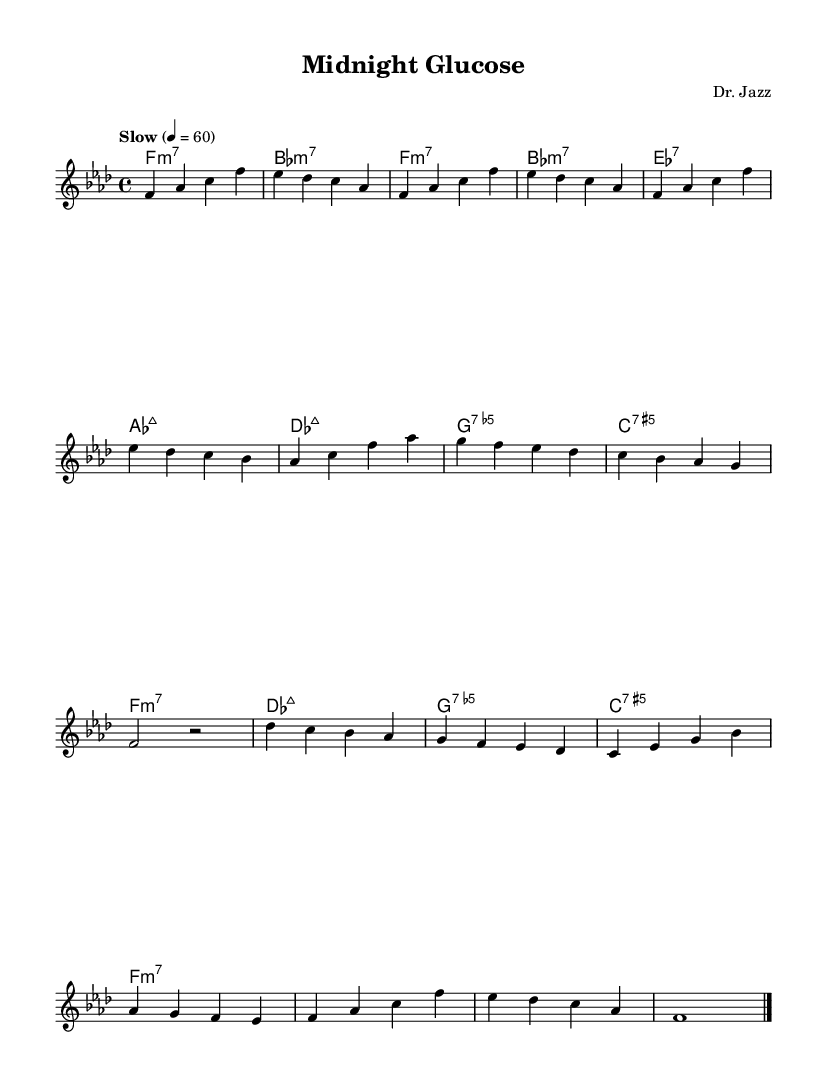What is the key signature of this music? The key signature indicated is F minor, which has four flats: B, E, A, and D. This can be identified by looking at the key signature at the beginning of the staff.
Answer: F minor What is the time signature of this piece? The time signature shown is 4/4, meaning there are four beats in each measure and a quarter note receives one beat. This information is displayed at the beginning of the sheet music.
Answer: 4/4 What is the tempo marking of this music? The tempo marking states "Slow" with a metronome marking of 60 beats per minute. This indicates that the piece is performed at a relaxed pace. The tempo is usually notated at the start of the score.
Answer: Slow, 60 Identify the first note in the melody. The first note of the melody is F, which appears at the beginning of the melody line. It is positioned on the fourth space of the treble staff.
Answer: F What chord is played in the first measure? The first measure contains the chord F minor 7, as denoted by the chord name below the staff. This chord is intended to be played simultaneously with the melody.
Answer: F minor 7 How many measures are in the A section? The A section consists of eight measures. This can be counted by identifying the measures in the melody section, each separated by vertical lines.
Answer: 8 What is the tonality shift in the B section regarding the chord progression? The B section introduces a change with the chords shifting from D flat major 7 to G minor 7, which suggests a movement from tonic to dominant in F minor. This can be analyzed by examining the chord changes notation below the melody.
Answer: D flat major 7 to G minor 7 